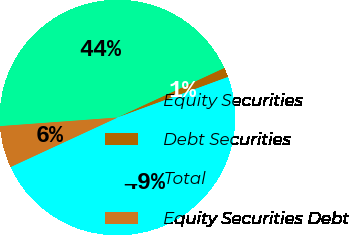Convert chart to OTSL. <chart><loc_0><loc_0><loc_500><loc_500><pie_chart><fcel>Equity Securities<fcel>Debt Securities<fcel>Total<fcel>Equity Securities Debt<nl><fcel>44.27%<fcel>1.3%<fcel>48.7%<fcel>5.73%<nl></chart> 